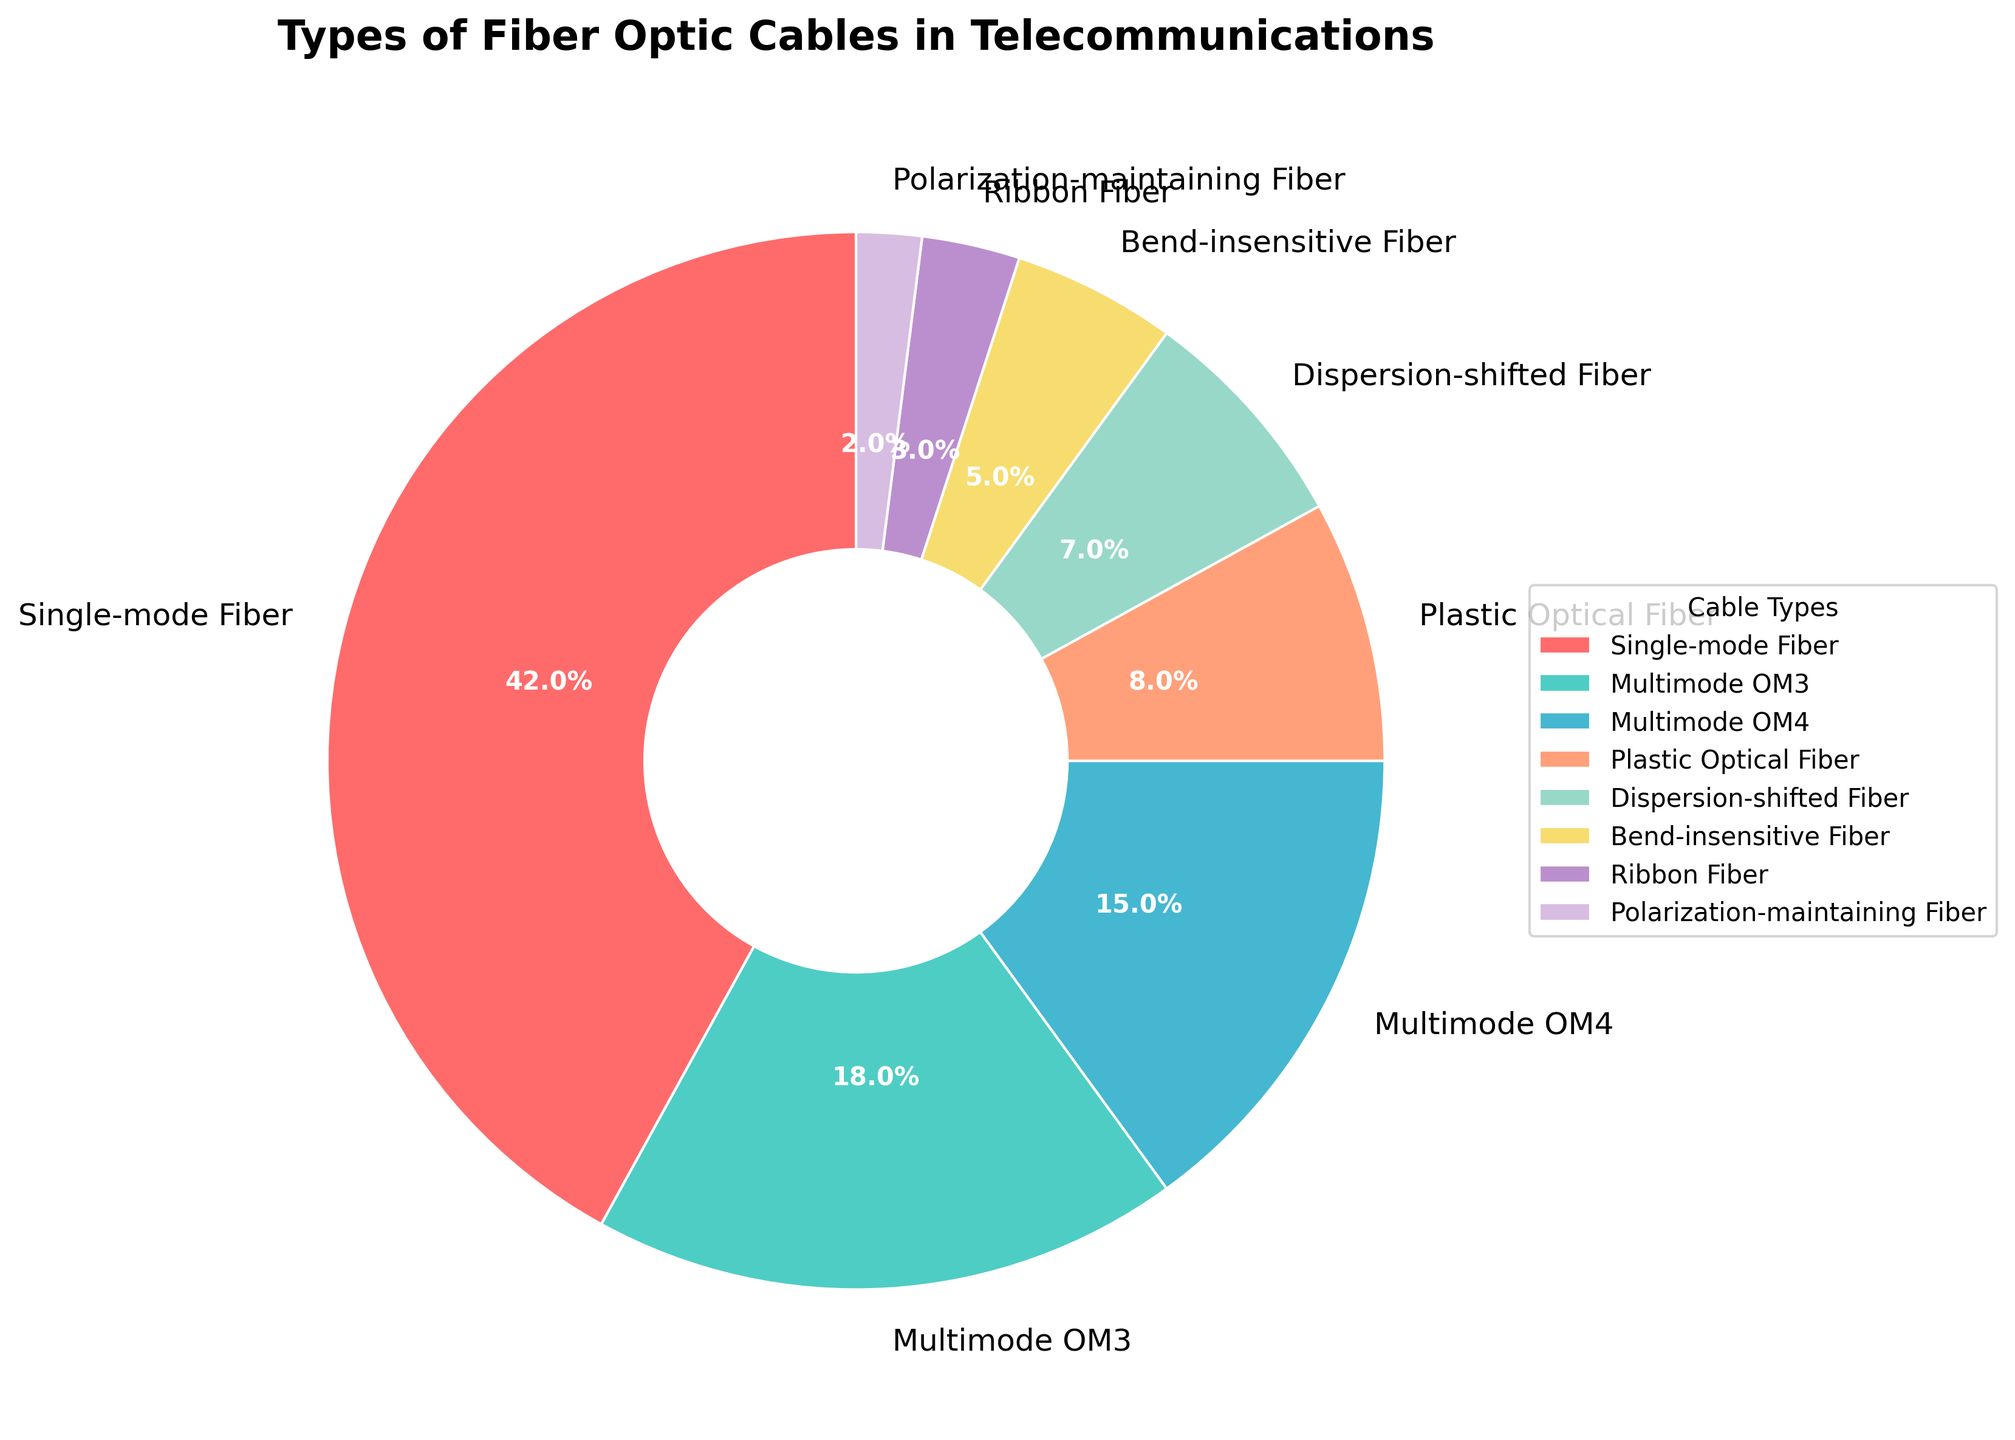Which type of fiber optic cable is the most used in telecommunications? The type with the largest percentage on the pie chart is Single-mode Fiber, which is 42%.
Answer: Single-mode Fiber What is the combined percentage of Multimode OM3 and Multimode OM4 cables? The percentages of Multimode OM3 and Multimode OM4 on the pie chart are 18% and 15% respectively. Adding them together gives 18% + 15% = 33%.
Answer: 33% Is the percentage of Plastic Optical Fiber cable higher or lower than Bend-insensitive Fiber cable? The pie chart shows that Plastic Optical Fiber has 8%, while Bend-insensitive Fiber has 5%. 8% is higher than 5%.
Answer: Higher How much more percentage does Single-mode Fiber have compared to Dispersion-shifted Fiber? The pie chart shows Single-mode Fiber with 42% and Dispersion-shifted Fiber with 7%. The difference is calculated as 42% - 7% = 35%.
Answer: 35% Which fiber optic cable type has the smallest percentage usage? The smallest percentage on the pie chart is for Polarization-maintaining Fiber, which has 2%.
Answer: Polarization-maintaining Fiber What is the total percentage of single-mode derived cables (Single-mode Fiber and Dispersion-shifted Fiber)? The pie chart shows Single-mode Fiber at 42% and Dispersion-shifted Fiber at 7%. Adding them together gives 42% + 7% = 49%.
Answer: 49% Among Bend-insensitive Fiber, Ribbon Fiber, and Polarization-maintaining Fiber, which one has the largest percentage? The pie chart shows Bend-insensitive Fiber at 5%, Ribbon Fiber at 3%, and Polarization-maintaining Fiber at 2%. The largest percentage among them is 5%.
Answer: Bend-insensitive Fiber 